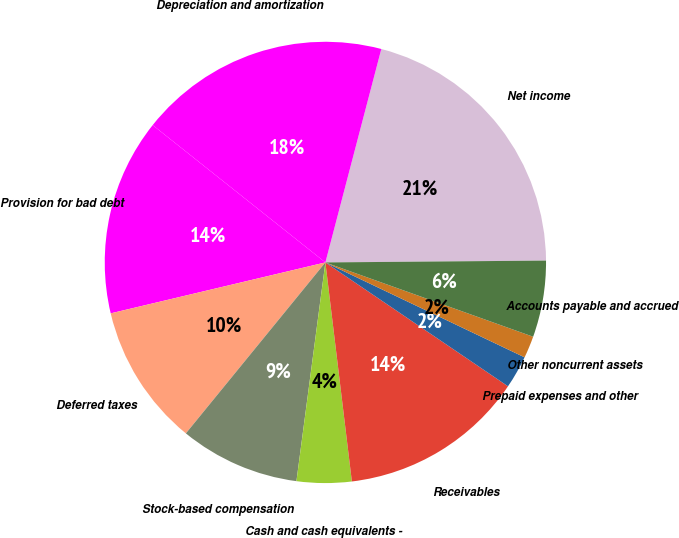Convert chart. <chart><loc_0><loc_0><loc_500><loc_500><pie_chart><fcel>Net income<fcel>Depreciation and amortization<fcel>Provision for bad debt<fcel>Deferred taxes<fcel>Stock-based compensation<fcel>Cash and cash equivalents -<fcel>Receivables<fcel>Prepaid expenses and other<fcel>Other noncurrent assets<fcel>Accounts payable and accrued<nl><fcel>20.79%<fcel>18.39%<fcel>14.4%<fcel>10.4%<fcel>8.8%<fcel>4.01%<fcel>13.6%<fcel>2.41%<fcel>1.61%<fcel>5.6%<nl></chart> 